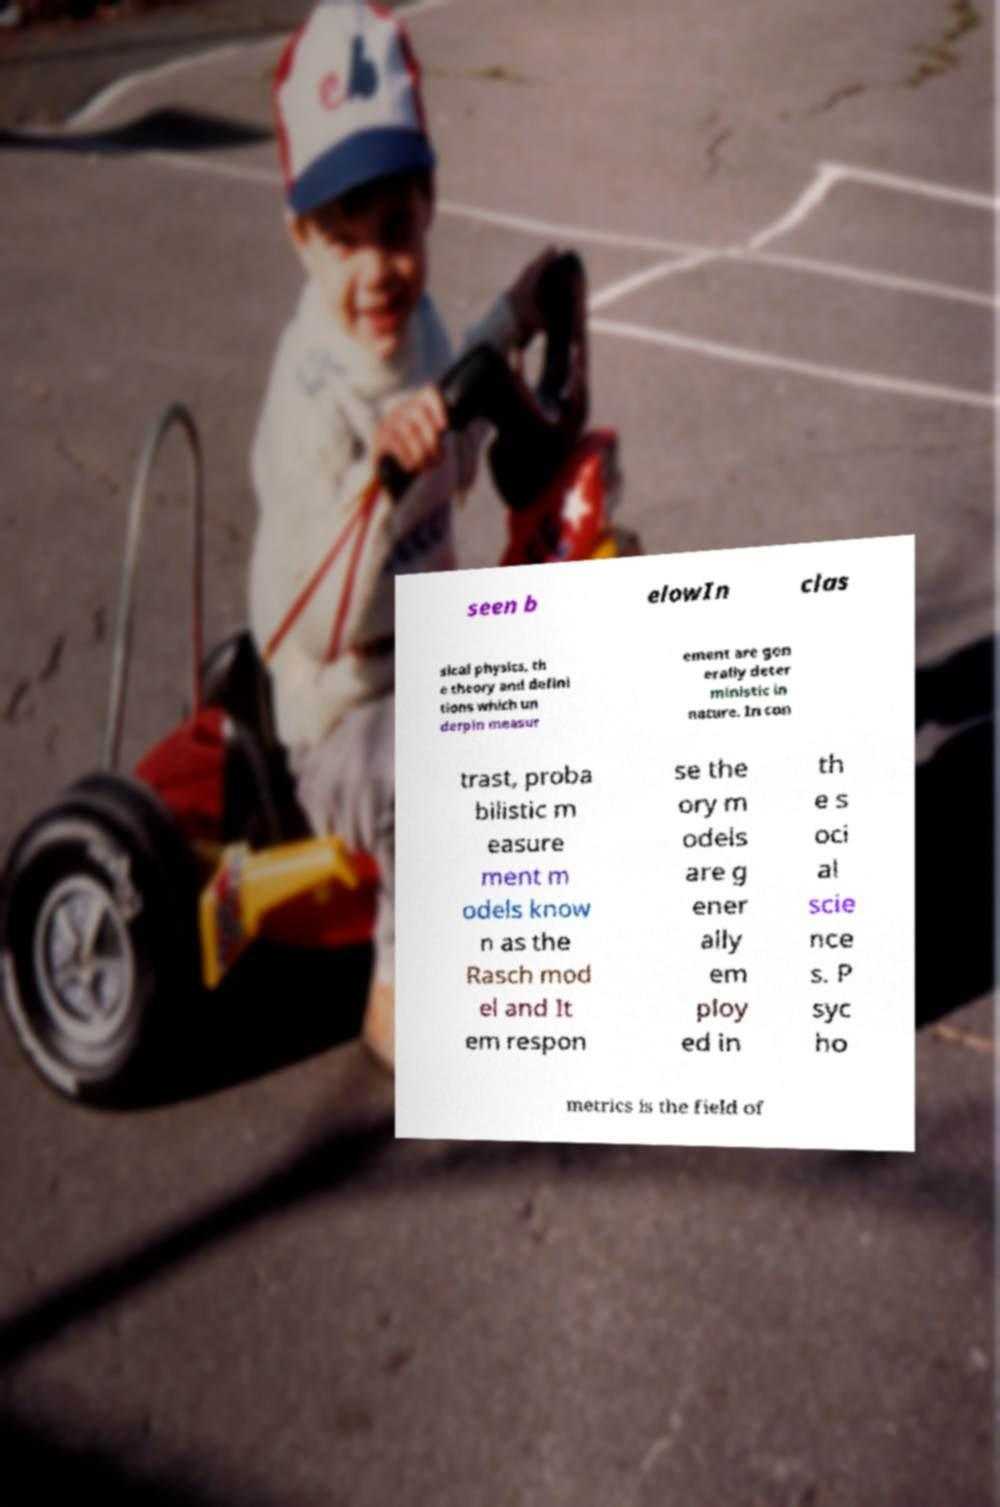Can you accurately transcribe the text from the provided image for me? seen b elowIn clas sical physics, th e theory and defini tions which un derpin measur ement are gen erally deter ministic in nature. In con trast, proba bilistic m easure ment m odels know n as the Rasch mod el and It em respon se the ory m odels are g ener ally em ploy ed in th e s oci al scie nce s. P syc ho metrics is the field of 